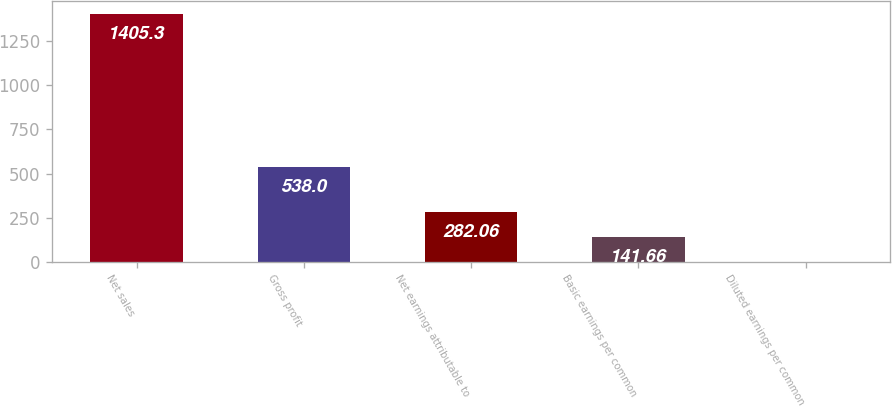<chart> <loc_0><loc_0><loc_500><loc_500><bar_chart><fcel>Net sales<fcel>Gross profit<fcel>Net earnings attributable to<fcel>Basic earnings per common<fcel>Diluted earnings per common<nl><fcel>1405.3<fcel>538<fcel>282.06<fcel>141.66<fcel>1.26<nl></chart> 